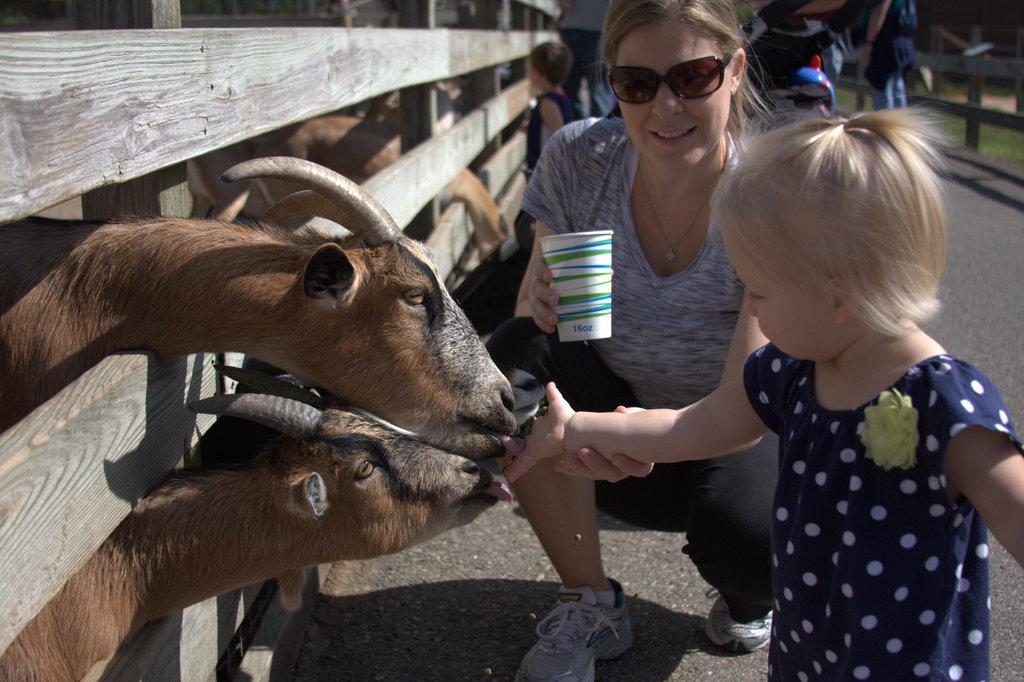Please provide a concise description of this image. In this picture there is a woman sitting like squat position and holding a cup, in front of her there is a girl standing and we can see animals and wooden fence. In the background of the image it is blurry and we can see kid, grass and animal. 